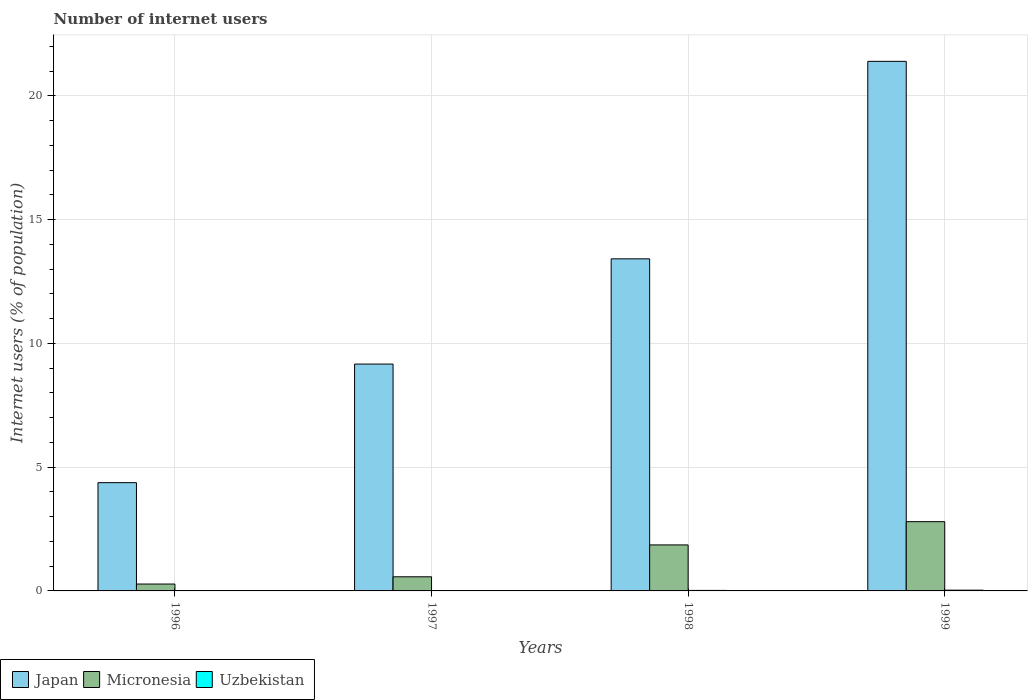How many bars are there on the 1st tick from the right?
Your response must be concise. 3. What is the label of the 4th group of bars from the left?
Provide a short and direct response. 1999. What is the number of internet users in Micronesia in 1997?
Provide a succinct answer. 0.57. Across all years, what is the maximum number of internet users in Japan?
Your answer should be very brief. 21.39. Across all years, what is the minimum number of internet users in Micronesia?
Your response must be concise. 0.28. In which year was the number of internet users in Micronesia minimum?
Make the answer very short. 1996. What is the total number of internet users in Uzbekistan in the graph?
Offer a very short reply. 0.07. What is the difference between the number of internet users in Uzbekistan in 1996 and that in 1997?
Your answer should be very brief. -0.01. What is the difference between the number of internet users in Uzbekistan in 1997 and the number of internet users in Micronesia in 1999?
Make the answer very short. -2.79. What is the average number of internet users in Uzbekistan per year?
Your response must be concise. 0.02. In the year 1997, what is the difference between the number of internet users in Micronesia and number of internet users in Japan?
Give a very brief answer. -8.59. What is the ratio of the number of internet users in Japan in 1998 to that in 1999?
Provide a succinct answer. 0.63. Is the number of internet users in Japan in 1998 less than that in 1999?
Offer a terse response. Yes. Is the difference between the number of internet users in Micronesia in 1997 and 1999 greater than the difference between the number of internet users in Japan in 1997 and 1999?
Your response must be concise. Yes. What is the difference between the highest and the second highest number of internet users in Japan?
Your answer should be very brief. 7.98. What is the difference between the highest and the lowest number of internet users in Japan?
Your response must be concise. 17.02. In how many years, is the number of internet users in Japan greater than the average number of internet users in Japan taken over all years?
Offer a very short reply. 2. What does the 3rd bar from the left in 1999 represents?
Give a very brief answer. Uzbekistan. What does the 2nd bar from the right in 1999 represents?
Your answer should be very brief. Micronesia. How many bars are there?
Your answer should be compact. 12. Are all the bars in the graph horizontal?
Give a very brief answer. No. What is the difference between two consecutive major ticks on the Y-axis?
Your answer should be compact. 5. Are the values on the major ticks of Y-axis written in scientific E-notation?
Provide a succinct answer. No. Does the graph contain any zero values?
Offer a terse response. No. Does the graph contain grids?
Provide a short and direct response. Yes. How many legend labels are there?
Make the answer very short. 3. What is the title of the graph?
Your answer should be compact. Number of internet users. Does "Zambia" appear as one of the legend labels in the graph?
Give a very brief answer. No. What is the label or title of the X-axis?
Provide a short and direct response. Years. What is the label or title of the Y-axis?
Ensure brevity in your answer.  Internet users (% of population). What is the Internet users (% of population) of Japan in 1996?
Provide a short and direct response. 4.37. What is the Internet users (% of population) in Micronesia in 1996?
Ensure brevity in your answer.  0.28. What is the Internet users (% of population) of Uzbekistan in 1996?
Provide a succinct answer. 0. What is the Internet users (% of population) of Japan in 1997?
Offer a terse response. 9.16. What is the Internet users (% of population) of Micronesia in 1997?
Provide a short and direct response. 0.57. What is the Internet users (% of population) of Uzbekistan in 1997?
Ensure brevity in your answer.  0.01. What is the Internet users (% of population) of Japan in 1998?
Provide a short and direct response. 13.41. What is the Internet users (% of population) of Micronesia in 1998?
Give a very brief answer. 1.86. What is the Internet users (% of population) of Uzbekistan in 1998?
Provide a succinct answer. 0.02. What is the Internet users (% of population) in Japan in 1999?
Offer a terse response. 21.39. What is the Internet users (% of population) in Micronesia in 1999?
Offer a very short reply. 2.8. What is the Internet users (% of population) in Uzbekistan in 1999?
Your response must be concise. 0.03. Across all years, what is the maximum Internet users (% of population) in Japan?
Ensure brevity in your answer.  21.39. Across all years, what is the maximum Internet users (% of population) in Micronesia?
Give a very brief answer. 2.8. Across all years, what is the maximum Internet users (% of population) of Uzbekistan?
Provide a succinct answer. 0.03. Across all years, what is the minimum Internet users (% of population) of Japan?
Your answer should be compact. 4.37. Across all years, what is the minimum Internet users (% of population) in Micronesia?
Offer a very short reply. 0.28. Across all years, what is the minimum Internet users (% of population) of Uzbekistan?
Give a very brief answer. 0. What is the total Internet users (% of population) in Japan in the graph?
Offer a very short reply. 48.34. What is the total Internet users (% of population) in Micronesia in the graph?
Make the answer very short. 5.5. What is the total Internet users (% of population) in Uzbekistan in the graph?
Provide a succinct answer. 0.07. What is the difference between the Internet users (% of population) in Japan in 1996 and that in 1997?
Ensure brevity in your answer.  -4.79. What is the difference between the Internet users (% of population) of Micronesia in 1996 and that in 1997?
Your response must be concise. -0.29. What is the difference between the Internet users (% of population) of Uzbekistan in 1996 and that in 1997?
Provide a short and direct response. -0.01. What is the difference between the Internet users (% of population) in Japan in 1996 and that in 1998?
Ensure brevity in your answer.  -9.04. What is the difference between the Internet users (% of population) in Micronesia in 1996 and that in 1998?
Offer a very short reply. -1.58. What is the difference between the Internet users (% of population) in Uzbekistan in 1996 and that in 1998?
Keep it short and to the point. -0.02. What is the difference between the Internet users (% of population) of Japan in 1996 and that in 1999?
Provide a succinct answer. -17.02. What is the difference between the Internet users (% of population) in Micronesia in 1996 and that in 1999?
Provide a short and direct response. -2.52. What is the difference between the Internet users (% of population) of Uzbekistan in 1996 and that in 1999?
Ensure brevity in your answer.  -0.03. What is the difference between the Internet users (% of population) in Japan in 1997 and that in 1998?
Give a very brief answer. -4.25. What is the difference between the Internet users (% of population) in Micronesia in 1997 and that in 1998?
Offer a very short reply. -1.29. What is the difference between the Internet users (% of population) of Uzbekistan in 1997 and that in 1998?
Give a very brief answer. -0.01. What is the difference between the Internet users (% of population) of Japan in 1997 and that in 1999?
Your response must be concise. -12.23. What is the difference between the Internet users (% of population) in Micronesia in 1997 and that in 1999?
Keep it short and to the point. -2.23. What is the difference between the Internet users (% of population) in Uzbekistan in 1997 and that in 1999?
Your answer should be compact. -0.02. What is the difference between the Internet users (% of population) in Japan in 1998 and that in 1999?
Your answer should be very brief. -7.98. What is the difference between the Internet users (% of population) of Micronesia in 1998 and that in 1999?
Your response must be concise. -0.94. What is the difference between the Internet users (% of population) of Uzbekistan in 1998 and that in 1999?
Offer a very short reply. -0.01. What is the difference between the Internet users (% of population) in Japan in 1996 and the Internet users (% of population) in Micronesia in 1997?
Provide a short and direct response. 3.8. What is the difference between the Internet users (% of population) in Japan in 1996 and the Internet users (% of population) in Uzbekistan in 1997?
Your answer should be compact. 4.36. What is the difference between the Internet users (% of population) in Micronesia in 1996 and the Internet users (% of population) in Uzbekistan in 1997?
Offer a very short reply. 0.27. What is the difference between the Internet users (% of population) in Japan in 1996 and the Internet users (% of population) in Micronesia in 1998?
Give a very brief answer. 2.51. What is the difference between the Internet users (% of population) in Japan in 1996 and the Internet users (% of population) in Uzbekistan in 1998?
Make the answer very short. 4.35. What is the difference between the Internet users (% of population) of Micronesia in 1996 and the Internet users (% of population) of Uzbekistan in 1998?
Your response must be concise. 0.26. What is the difference between the Internet users (% of population) of Japan in 1996 and the Internet users (% of population) of Micronesia in 1999?
Your answer should be very brief. 1.58. What is the difference between the Internet users (% of population) in Japan in 1996 and the Internet users (% of population) in Uzbekistan in 1999?
Your answer should be very brief. 4.34. What is the difference between the Internet users (% of population) in Micronesia in 1996 and the Internet users (% of population) in Uzbekistan in 1999?
Make the answer very short. 0.25. What is the difference between the Internet users (% of population) in Japan in 1997 and the Internet users (% of population) in Micronesia in 1998?
Ensure brevity in your answer.  7.3. What is the difference between the Internet users (% of population) in Japan in 1997 and the Internet users (% of population) in Uzbekistan in 1998?
Provide a succinct answer. 9.14. What is the difference between the Internet users (% of population) of Micronesia in 1997 and the Internet users (% of population) of Uzbekistan in 1998?
Make the answer very short. 0.55. What is the difference between the Internet users (% of population) in Japan in 1997 and the Internet users (% of population) in Micronesia in 1999?
Provide a short and direct response. 6.37. What is the difference between the Internet users (% of population) of Japan in 1997 and the Internet users (% of population) of Uzbekistan in 1999?
Ensure brevity in your answer.  9.13. What is the difference between the Internet users (% of population) of Micronesia in 1997 and the Internet users (% of population) of Uzbekistan in 1999?
Provide a short and direct response. 0.54. What is the difference between the Internet users (% of population) in Japan in 1998 and the Internet users (% of population) in Micronesia in 1999?
Your answer should be compact. 10.62. What is the difference between the Internet users (% of population) of Japan in 1998 and the Internet users (% of population) of Uzbekistan in 1999?
Your response must be concise. 13.38. What is the difference between the Internet users (% of population) in Micronesia in 1998 and the Internet users (% of population) in Uzbekistan in 1999?
Your response must be concise. 1.83. What is the average Internet users (% of population) of Japan per year?
Offer a very short reply. 12.09. What is the average Internet users (% of population) in Micronesia per year?
Your answer should be very brief. 1.38. What is the average Internet users (% of population) of Uzbekistan per year?
Give a very brief answer. 0.02. In the year 1996, what is the difference between the Internet users (% of population) in Japan and Internet users (% of population) in Micronesia?
Your answer should be very brief. 4.09. In the year 1996, what is the difference between the Internet users (% of population) in Japan and Internet users (% of population) in Uzbekistan?
Make the answer very short. 4.37. In the year 1996, what is the difference between the Internet users (% of population) in Micronesia and Internet users (% of population) in Uzbekistan?
Provide a short and direct response. 0.27. In the year 1997, what is the difference between the Internet users (% of population) in Japan and Internet users (% of population) in Micronesia?
Your answer should be compact. 8.59. In the year 1997, what is the difference between the Internet users (% of population) of Japan and Internet users (% of population) of Uzbekistan?
Your answer should be compact. 9.15. In the year 1997, what is the difference between the Internet users (% of population) of Micronesia and Internet users (% of population) of Uzbekistan?
Make the answer very short. 0.56. In the year 1998, what is the difference between the Internet users (% of population) of Japan and Internet users (% of population) of Micronesia?
Your response must be concise. 11.56. In the year 1998, what is the difference between the Internet users (% of population) in Japan and Internet users (% of population) in Uzbekistan?
Provide a short and direct response. 13.39. In the year 1998, what is the difference between the Internet users (% of population) in Micronesia and Internet users (% of population) in Uzbekistan?
Give a very brief answer. 1.84. In the year 1999, what is the difference between the Internet users (% of population) in Japan and Internet users (% of population) in Micronesia?
Offer a terse response. 18.59. In the year 1999, what is the difference between the Internet users (% of population) in Japan and Internet users (% of population) in Uzbekistan?
Keep it short and to the point. 21.36. In the year 1999, what is the difference between the Internet users (% of population) in Micronesia and Internet users (% of population) in Uzbekistan?
Offer a terse response. 2.77. What is the ratio of the Internet users (% of population) in Japan in 1996 to that in 1997?
Provide a succinct answer. 0.48. What is the ratio of the Internet users (% of population) of Micronesia in 1996 to that in 1997?
Your answer should be compact. 0.49. What is the ratio of the Internet users (% of population) in Uzbekistan in 1996 to that in 1997?
Your response must be concise. 0.41. What is the ratio of the Internet users (% of population) in Japan in 1996 to that in 1998?
Your answer should be compact. 0.33. What is the ratio of the Internet users (% of population) of Micronesia in 1996 to that in 1998?
Offer a terse response. 0.15. What is the ratio of the Internet users (% of population) in Uzbekistan in 1996 to that in 1998?
Your answer should be very brief. 0.21. What is the ratio of the Internet users (% of population) of Japan in 1996 to that in 1999?
Keep it short and to the point. 0.2. What is the ratio of the Internet users (% of population) of Micronesia in 1996 to that in 1999?
Keep it short and to the point. 0.1. What is the ratio of the Internet users (% of population) in Uzbekistan in 1996 to that in 1999?
Your answer should be compact. 0.14. What is the ratio of the Internet users (% of population) in Japan in 1997 to that in 1998?
Offer a very short reply. 0.68. What is the ratio of the Internet users (% of population) in Micronesia in 1997 to that in 1998?
Your response must be concise. 0.31. What is the ratio of the Internet users (% of population) in Uzbekistan in 1997 to that in 1998?
Make the answer very short. 0.51. What is the ratio of the Internet users (% of population) in Japan in 1997 to that in 1999?
Provide a succinct answer. 0.43. What is the ratio of the Internet users (% of population) in Micronesia in 1997 to that in 1999?
Provide a short and direct response. 0.2. What is the ratio of the Internet users (% of population) in Uzbekistan in 1997 to that in 1999?
Provide a succinct answer. 0.34. What is the ratio of the Internet users (% of population) of Japan in 1998 to that in 1999?
Offer a very short reply. 0.63. What is the ratio of the Internet users (% of population) in Micronesia in 1998 to that in 1999?
Provide a succinct answer. 0.66. What is the ratio of the Internet users (% of population) in Uzbekistan in 1998 to that in 1999?
Your response must be concise. 0.68. What is the difference between the highest and the second highest Internet users (% of population) of Japan?
Your answer should be very brief. 7.98. What is the difference between the highest and the second highest Internet users (% of population) in Micronesia?
Make the answer very short. 0.94. What is the difference between the highest and the second highest Internet users (% of population) in Uzbekistan?
Make the answer very short. 0.01. What is the difference between the highest and the lowest Internet users (% of population) of Japan?
Your answer should be very brief. 17.02. What is the difference between the highest and the lowest Internet users (% of population) in Micronesia?
Offer a terse response. 2.52. What is the difference between the highest and the lowest Internet users (% of population) of Uzbekistan?
Your response must be concise. 0.03. 